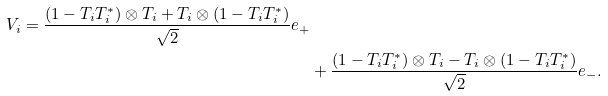Convert formula to latex. <formula><loc_0><loc_0><loc_500><loc_500>{ V _ { i } = \frac { ( 1 - T _ { i } T _ { i } ^ { * } ) \otimes T _ { i } + T _ { i } \otimes ( 1 - T _ { i } T _ { i } ^ { * } ) } { \sqrt { 2 } } e _ { + } } \\ & + \frac { ( 1 - T _ { i } T _ { i } ^ { * } ) \otimes T _ { i } - T _ { i } \otimes ( 1 - T _ { i } T _ { i } ^ { * } ) } { \sqrt { 2 } } e _ { - } .</formula> 